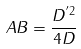<formula> <loc_0><loc_0><loc_500><loc_500>A B = \frac { D ^ { ^ { \prime } 2 } } { 4 D }</formula> 